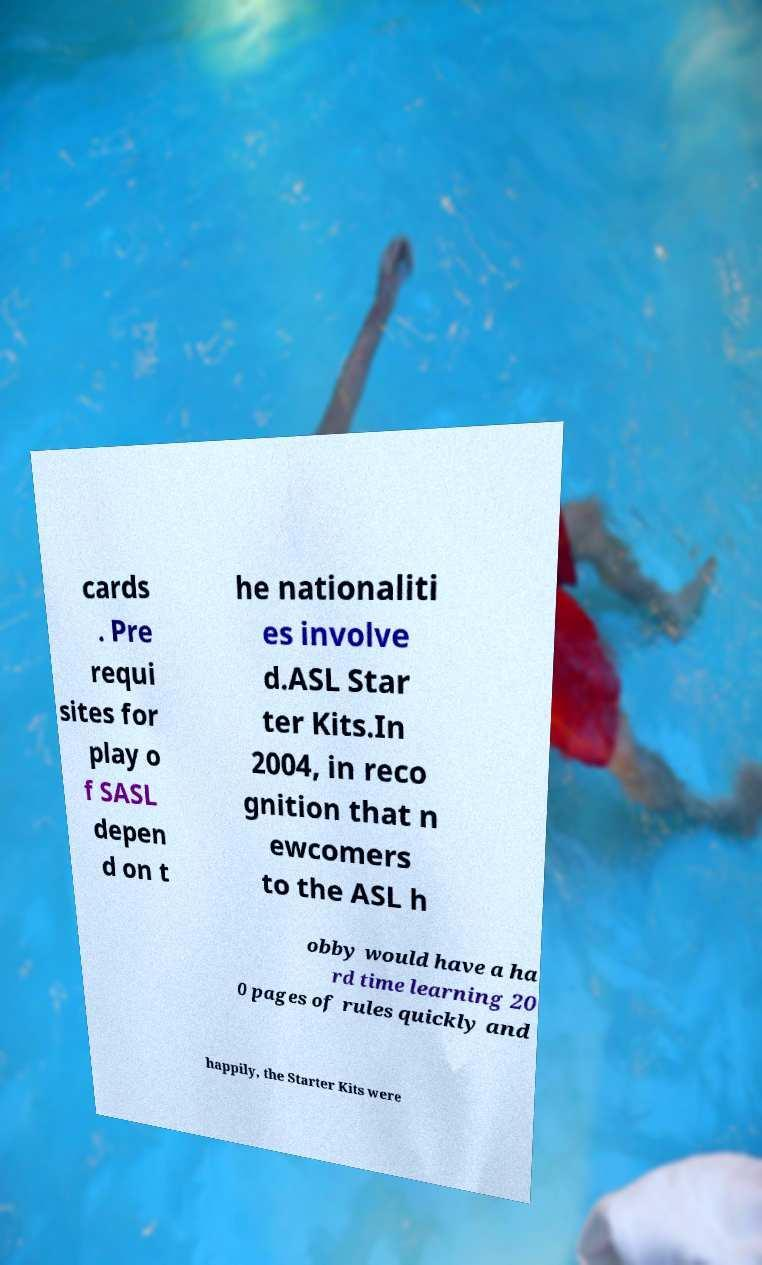What messages or text are displayed in this image? I need them in a readable, typed format. cards . Pre requi sites for play o f SASL depen d on t he nationaliti es involve d.ASL Star ter Kits.In 2004, in reco gnition that n ewcomers to the ASL h obby would have a ha rd time learning 20 0 pages of rules quickly and happily, the Starter Kits were 